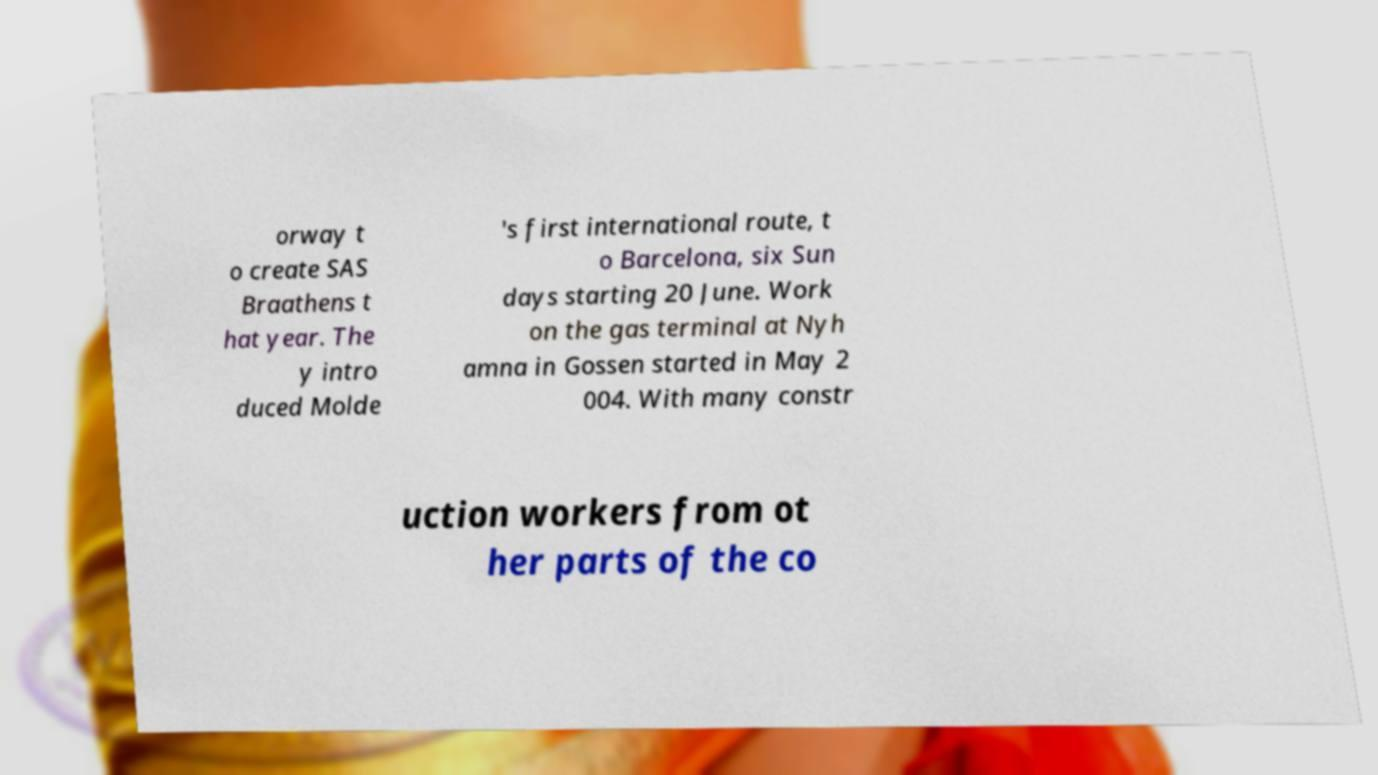Could you assist in decoding the text presented in this image and type it out clearly? orway t o create SAS Braathens t hat year. The y intro duced Molde 's first international route, t o Barcelona, six Sun days starting 20 June. Work on the gas terminal at Nyh amna in Gossen started in May 2 004. With many constr uction workers from ot her parts of the co 